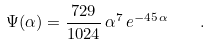<formula> <loc_0><loc_0><loc_500><loc_500>\Psi ( \alpha ) = \frac { 7 2 9 } { 1 0 2 4 } \, \alpha ^ { 7 } \, e ^ { - 4 5 \, \alpha } \quad .</formula> 